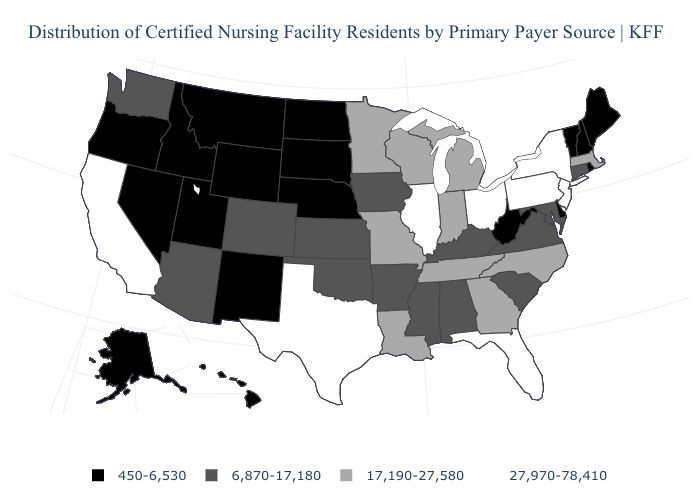What is the value of Wyoming?
Write a very short answer. 450-6,530. What is the value of Vermont?
Quick response, please. 450-6,530. Which states have the lowest value in the South?
Quick response, please. Delaware, West Virginia. Which states have the highest value in the USA?
Short answer required. California, Florida, Illinois, New Jersey, New York, Ohio, Pennsylvania, Texas. Does Hawaii have the same value as Wisconsin?
Keep it brief. No. How many symbols are there in the legend?
Give a very brief answer. 4. What is the value of Colorado?
Short answer required. 6,870-17,180. Does the map have missing data?
Keep it brief. No. Name the states that have a value in the range 6,870-17,180?
Short answer required. Alabama, Arizona, Arkansas, Colorado, Connecticut, Iowa, Kansas, Kentucky, Maryland, Mississippi, Oklahoma, South Carolina, Virginia, Washington. Does the first symbol in the legend represent the smallest category?
Write a very short answer. Yes. Which states hav the highest value in the South?
Short answer required. Florida, Texas. What is the highest value in the MidWest ?
Short answer required. 27,970-78,410. What is the highest value in the MidWest ?
Write a very short answer. 27,970-78,410. What is the highest value in the Northeast ?
Write a very short answer. 27,970-78,410. Among the states that border Florida , which have the lowest value?
Quick response, please. Alabama. 